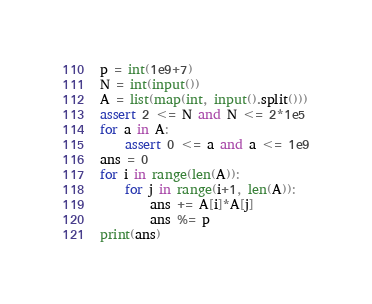Convert code to text. <code><loc_0><loc_0><loc_500><loc_500><_Python_>p = int(1e9+7)
N = int(input())
A = list(map(int, input().split()))
assert 2 <= N and N <= 2*1e5
for a in A:
    assert 0 <= a and a <= 1e9
ans = 0
for i in range(len(A)):
    for j in range(i+1, len(A)):
        ans += A[i]*A[j] 
        ans %= p
print(ans)</code> 